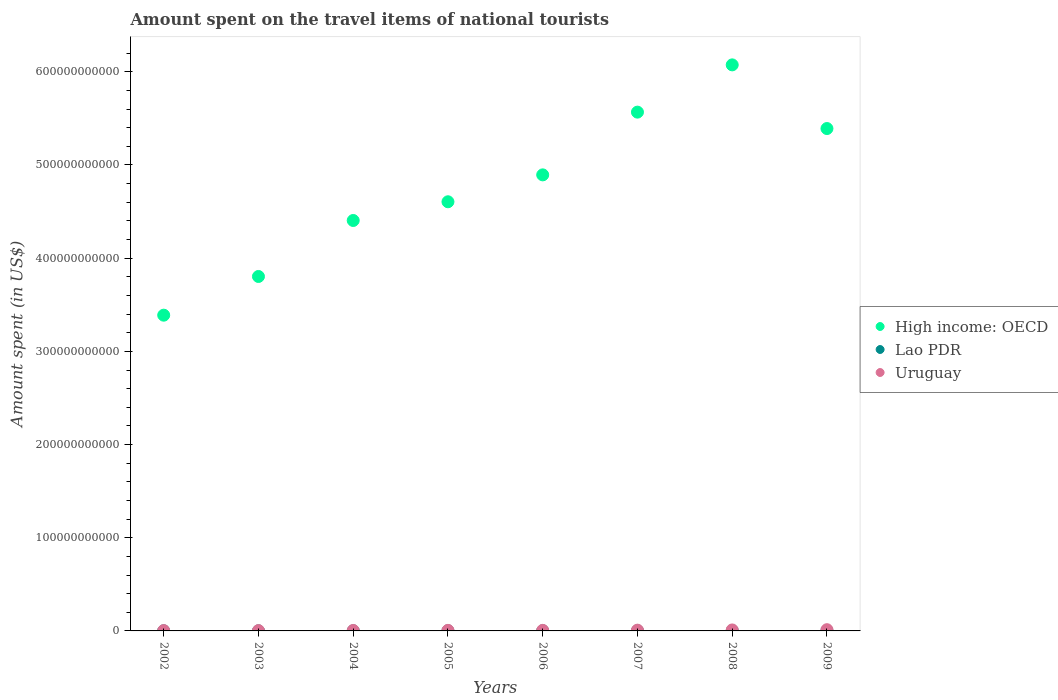How many different coloured dotlines are there?
Your answer should be very brief. 3. Is the number of dotlines equal to the number of legend labels?
Your response must be concise. Yes. What is the amount spent on the travel items of national tourists in High income: OECD in 2005?
Keep it short and to the point. 4.61e+11. Across all years, what is the maximum amount spent on the travel items of national tourists in Uruguay?
Ensure brevity in your answer.  1.32e+09. Across all years, what is the minimum amount spent on the travel items of national tourists in Lao PDR?
Make the answer very short. 7.40e+07. In which year was the amount spent on the travel items of national tourists in Lao PDR minimum?
Your response must be concise. 2003. What is the total amount spent on the travel items of national tourists in Lao PDR in the graph?
Offer a terse response. 1.33e+09. What is the difference between the amount spent on the travel items of national tourists in Lao PDR in 2004 and that in 2009?
Offer a terse response. -1.49e+08. What is the difference between the amount spent on the travel items of national tourists in Lao PDR in 2003 and the amount spent on the travel items of national tourists in Uruguay in 2009?
Keep it short and to the point. -1.25e+09. What is the average amount spent on the travel items of national tourists in High income: OECD per year?
Provide a succinct answer. 4.77e+11. In the year 2004, what is the difference between the amount spent on the travel items of national tourists in Lao PDR and amount spent on the travel items of national tourists in High income: OECD?
Provide a succinct answer. -4.40e+11. In how many years, is the amount spent on the travel items of national tourists in High income: OECD greater than 260000000000 US$?
Ensure brevity in your answer.  8. What is the ratio of the amount spent on the travel items of national tourists in Uruguay in 2006 to that in 2009?
Provide a short and direct response. 0.45. Is the difference between the amount spent on the travel items of national tourists in Lao PDR in 2006 and 2007 greater than the difference between the amount spent on the travel items of national tourists in High income: OECD in 2006 and 2007?
Provide a succinct answer. Yes. What is the difference between the highest and the second highest amount spent on the travel items of national tourists in High income: OECD?
Offer a terse response. 5.07e+1. What is the difference between the highest and the lowest amount spent on the travel items of national tourists in Lao PDR?
Provide a succinct answer. 2.02e+08. In how many years, is the amount spent on the travel items of national tourists in High income: OECD greater than the average amount spent on the travel items of national tourists in High income: OECD taken over all years?
Your answer should be compact. 4. Is it the case that in every year, the sum of the amount spent on the travel items of national tourists in High income: OECD and amount spent on the travel items of national tourists in Lao PDR  is greater than the amount spent on the travel items of national tourists in Uruguay?
Your response must be concise. Yes. Is the amount spent on the travel items of national tourists in Uruguay strictly greater than the amount spent on the travel items of national tourists in High income: OECD over the years?
Provide a short and direct response. No. Is the amount spent on the travel items of national tourists in High income: OECD strictly less than the amount spent on the travel items of national tourists in Uruguay over the years?
Give a very brief answer. No. How many years are there in the graph?
Make the answer very short. 8. What is the difference between two consecutive major ticks on the Y-axis?
Keep it short and to the point. 1.00e+11. Does the graph contain any zero values?
Your response must be concise. No. Does the graph contain grids?
Your answer should be compact. No. How are the legend labels stacked?
Offer a terse response. Vertical. What is the title of the graph?
Offer a very short reply. Amount spent on the travel items of national tourists. What is the label or title of the X-axis?
Your answer should be compact. Years. What is the label or title of the Y-axis?
Your answer should be very brief. Amount spent (in US$). What is the Amount spent (in US$) of High income: OECD in 2002?
Offer a terse response. 3.39e+11. What is the Amount spent (in US$) in Lao PDR in 2002?
Keep it short and to the point. 1.07e+08. What is the Amount spent (in US$) of Uruguay in 2002?
Provide a short and direct response. 3.51e+08. What is the Amount spent (in US$) of High income: OECD in 2003?
Keep it short and to the point. 3.80e+11. What is the Amount spent (in US$) in Lao PDR in 2003?
Ensure brevity in your answer.  7.40e+07. What is the Amount spent (in US$) of Uruguay in 2003?
Your answer should be very brief. 3.45e+08. What is the Amount spent (in US$) of High income: OECD in 2004?
Your response must be concise. 4.40e+11. What is the Amount spent (in US$) in Lao PDR in 2004?
Keep it short and to the point. 1.19e+08. What is the Amount spent (in US$) of Uruguay in 2004?
Offer a terse response. 4.94e+08. What is the Amount spent (in US$) in High income: OECD in 2005?
Keep it short and to the point. 4.61e+11. What is the Amount spent (in US$) of Lao PDR in 2005?
Keep it short and to the point. 1.39e+08. What is the Amount spent (in US$) in Uruguay in 2005?
Offer a very short reply. 5.94e+08. What is the Amount spent (in US$) in High income: OECD in 2006?
Ensure brevity in your answer.  4.89e+11. What is the Amount spent (in US$) of Lao PDR in 2006?
Your answer should be compact. 1.58e+08. What is the Amount spent (in US$) in Uruguay in 2006?
Ensure brevity in your answer.  5.98e+08. What is the Amount spent (in US$) in High income: OECD in 2007?
Provide a short and direct response. 5.57e+11. What is the Amount spent (in US$) in Lao PDR in 2007?
Offer a very short reply. 1.89e+08. What is the Amount spent (in US$) of Uruguay in 2007?
Offer a very short reply. 8.09e+08. What is the Amount spent (in US$) in High income: OECD in 2008?
Your response must be concise. 6.07e+11. What is the Amount spent (in US$) of Lao PDR in 2008?
Your answer should be very brief. 2.76e+08. What is the Amount spent (in US$) of Uruguay in 2008?
Offer a very short reply. 1.05e+09. What is the Amount spent (in US$) in High income: OECD in 2009?
Provide a short and direct response. 5.39e+11. What is the Amount spent (in US$) of Lao PDR in 2009?
Your answer should be compact. 2.68e+08. What is the Amount spent (in US$) in Uruguay in 2009?
Your response must be concise. 1.32e+09. Across all years, what is the maximum Amount spent (in US$) in High income: OECD?
Make the answer very short. 6.07e+11. Across all years, what is the maximum Amount spent (in US$) in Lao PDR?
Offer a very short reply. 2.76e+08. Across all years, what is the maximum Amount spent (in US$) in Uruguay?
Provide a short and direct response. 1.32e+09. Across all years, what is the minimum Amount spent (in US$) in High income: OECD?
Provide a succinct answer. 3.39e+11. Across all years, what is the minimum Amount spent (in US$) of Lao PDR?
Provide a succinct answer. 7.40e+07. Across all years, what is the minimum Amount spent (in US$) of Uruguay?
Ensure brevity in your answer.  3.45e+08. What is the total Amount spent (in US$) of High income: OECD in the graph?
Your answer should be very brief. 3.81e+12. What is the total Amount spent (in US$) of Lao PDR in the graph?
Offer a terse response. 1.33e+09. What is the total Amount spent (in US$) in Uruguay in the graph?
Your answer should be compact. 5.56e+09. What is the difference between the Amount spent (in US$) of High income: OECD in 2002 and that in 2003?
Make the answer very short. -4.15e+1. What is the difference between the Amount spent (in US$) of Lao PDR in 2002 and that in 2003?
Provide a succinct answer. 3.30e+07. What is the difference between the Amount spent (in US$) in High income: OECD in 2002 and that in 2004?
Offer a terse response. -1.02e+11. What is the difference between the Amount spent (in US$) in Lao PDR in 2002 and that in 2004?
Keep it short and to the point. -1.20e+07. What is the difference between the Amount spent (in US$) of Uruguay in 2002 and that in 2004?
Offer a terse response. -1.43e+08. What is the difference between the Amount spent (in US$) in High income: OECD in 2002 and that in 2005?
Your response must be concise. -1.22e+11. What is the difference between the Amount spent (in US$) in Lao PDR in 2002 and that in 2005?
Your answer should be compact. -3.20e+07. What is the difference between the Amount spent (in US$) in Uruguay in 2002 and that in 2005?
Make the answer very short. -2.43e+08. What is the difference between the Amount spent (in US$) of High income: OECD in 2002 and that in 2006?
Provide a succinct answer. -1.51e+11. What is the difference between the Amount spent (in US$) of Lao PDR in 2002 and that in 2006?
Provide a short and direct response. -5.10e+07. What is the difference between the Amount spent (in US$) of Uruguay in 2002 and that in 2006?
Offer a very short reply. -2.47e+08. What is the difference between the Amount spent (in US$) in High income: OECD in 2002 and that in 2007?
Your response must be concise. -2.18e+11. What is the difference between the Amount spent (in US$) of Lao PDR in 2002 and that in 2007?
Your answer should be very brief. -8.20e+07. What is the difference between the Amount spent (in US$) in Uruguay in 2002 and that in 2007?
Your response must be concise. -4.58e+08. What is the difference between the Amount spent (in US$) of High income: OECD in 2002 and that in 2008?
Your answer should be compact. -2.69e+11. What is the difference between the Amount spent (in US$) in Lao PDR in 2002 and that in 2008?
Offer a very short reply. -1.69e+08. What is the difference between the Amount spent (in US$) of Uruguay in 2002 and that in 2008?
Provide a succinct answer. -7.00e+08. What is the difference between the Amount spent (in US$) in High income: OECD in 2002 and that in 2009?
Your answer should be compact. -2.00e+11. What is the difference between the Amount spent (in US$) of Lao PDR in 2002 and that in 2009?
Your answer should be compact. -1.61e+08. What is the difference between the Amount spent (in US$) in Uruguay in 2002 and that in 2009?
Offer a very short reply. -9.70e+08. What is the difference between the Amount spent (in US$) in High income: OECD in 2003 and that in 2004?
Provide a succinct answer. -6.01e+1. What is the difference between the Amount spent (in US$) of Lao PDR in 2003 and that in 2004?
Your response must be concise. -4.50e+07. What is the difference between the Amount spent (in US$) in Uruguay in 2003 and that in 2004?
Make the answer very short. -1.49e+08. What is the difference between the Amount spent (in US$) of High income: OECD in 2003 and that in 2005?
Ensure brevity in your answer.  -8.02e+1. What is the difference between the Amount spent (in US$) of Lao PDR in 2003 and that in 2005?
Your answer should be very brief. -6.50e+07. What is the difference between the Amount spent (in US$) of Uruguay in 2003 and that in 2005?
Your answer should be very brief. -2.49e+08. What is the difference between the Amount spent (in US$) in High income: OECD in 2003 and that in 2006?
Give a very brief answer. -1.09e+11. What is the difference between the Amount spent (in US$) in Lao PDR in 2003 and that in 2006?
Keep it short and to the point. -8.40e+07. What is the difference between the Amount spent (in US$) in Uruguay in 2003 and that in 2006?
Your answer should be very brief. -2.53e+08. What is the difference between the Amount spent (in US$) of High income: OECD in 2003 and that in 2007?
Make the answer very short. -1.76e+11. What is the difference between the Amount spent (in US$) of Lao PDR in 2003 and that in 2007?
Your answer should be compact. -1.15e+08. What is the difference between the Amount spent (in US$) of Uruguay in 2003 and that in 2007?
Keep it short and to the point. -4.64e+08. What is the difference between the Amount spent (in US$) in High income: OECD in 2003 and that in 2008?
Your response must be concise. -2.27e+11. What is the difference between the Amount spent (in US$) of Lao PDR in 2003 and that in 2008?
Ensure brevity in your answer.  -2.02e+08. What is the difference between the Amount spent (in US$) in Uruguay in 2003 and that in 2008?
Ensure brevity in your answer.  -7.06e+08. What is the difference between the Amount spent (in US$) of High income: OECD in 2003 and that in 2009?
Your answer should be compact. -1.59e+11. What is the difference between the Amount spent (in US$) of Lao PDR in 2003 and that in 2009?
Provide a succinct answer. -1.94e+08. What is the difference between the Amount spent (in US$) of Uruguay in 2003 and that in 2009?
Provide a short and direct response. -9.76e+08. What is the difference between the Amount spent (in US$) in High income: OECD in 2004 and that in 2005?
Your answer should be very brief. -2.01e+1. What is the difference between the Amount spent (in US$) of Lao PDR in 2004 and that in 2005?
Your answer should be compact. -2.00e+07. What is the difference between the Amount spent (in US$) of Uruguay in 2004 and that in 2005?
Give a very brief answer. -1.00e+08. What is the difference between the Amount spent (in US$) in High income: OECD in 2004 and that in 2006?
Offer a terse response. -4.90e+1. What is the difference between the Amount spent (in US$) of Lao PDR in 2004 and that in 2006?
Give a very brief answer. -3.90e+07. What is the difference between the Amount spent (in US$) in Uruguay in 2004 and that in 2006?
Give a very brief answer. -1.04e+08. What is the difference between the Amount spent (in US$) in High income: OECD in 2004 and that in 2007?
Provide a short and direct response. -1.16e+11. What is the difference between the Amount spent (in US$) of Lao PDR in 2004 and that in 2007?
Your answer should be compact. -7.00e+07. What is the difference between the Amount spent (in US$) of Uruguay in 2004 and that in 2007?
Your response must be concise. -3.15e+08. What is the difference between the Amount spent (in US$) of High income: OECD in 2004 and that in 2008?
Offer a terse response. -1.67e+11. What is the difference between the Amount spent (in US$) of Lao PDR in 2004 and that in 2008?
Provide a succinct answer. -1.57e+08. What is the difference between the Amount spent (in US$) in Uruguay in 2004 and that in 2008?
Provide a short and direct response. -5.57e+08. What is the difference between the Amount spent (in US$) in High income: OECD in 2004 and that in 2009?
Offer a very short reply. -9.87e+1. What is the difference between the Amount spent (in US$) in Lao PDR in 2004 and that in 2009?
Ensure brevity in your answer.  -1.49e+08. What is the difference between the Amount spent (in US$) of Uruguay in 2004 and that in 2009?
Provide a short and direct response. -8.27e+08. What is the difference between the Amount spent (in US$) of High income: OECD in 2005 and that in 2006?
Your response must be concise. -2.89e+1. What is the difference between the Amount spent (in US$) in Lao PDR in 2005 and that in 2006?
Keep it short and to the point. -1.90e+07. What is the difference between the Amount spent (in US$) in Uruguay in 2005 and that in 2006?
Your response must be concise. -4.00e+06. What is the difference between the Amount spent (in US$) in High income: OECD in 2005 and that in 2007?
Your response must be concise. -9.62e+1. What is the difference between the Amount spent (in US$) of Lao PDR in 2005 and that in 2007?
Offer a terse response. -5.00e+07. What is the difference between the Amount spent (in US$) of Uruguay in 2005 and that in 2007?
Keep it short and to the point. -2.15e+08. What is the difference between the Amount spent (in US$) of High income: OECD in 2005 and that in 2008?
Provide a short and direct response. -1.47e+11. What is the difference between the Amount spent (in US$) of Lao PDR in 2005 and that in 2008?
Offer a terse response. -1.37e+08. What is the difference between the Amount spent (in US$) in Uruguay in 2005 and that in 2008?
Ensure brevity in your answer.  -4.57e+08. What is the difference between the Amount spent (in US$) of High income: OECD in 2005 and that in 2009?
Your response must be concise. -7.86e+1. What is the difference between the Amount spent (in US$) in Lao PDR in 2005 and that in 2009?
Ensure brevity in your answer.  -1.29e+08. What is the difference between the Amount spent (in US$) in Uruguay in 2005 and that in 2009?
Keep it short and to the point. -7.27e+08. What is the difference between the Amount spent (in US$) in High income: OECD in 2006 and that in 2007?
Provide a short and direct response. -6.73e+1. What is the difference between the Amount spent (in US$) in Lao PDR in 2006 and that in 2007?
Keep it short and to the point. -3.10e+07. What is the difference between the Amount spent (in US$) in Uruguay in 2006 and that in 2007?
Ensure brevity in your answer.  -2.11e+08. What is the difference between the Amount spent (in US$) in High income: OECD in 2006 and that in 2008?
Your response must be concise. -1.18e+11. What is the difference between the Amount spent (in US$) in Lao PDR in 2006 and that in 2008?
Provide a succinct answer. -1.18e+08. What is the difference between the Amount spent (in US$) in Uruguay in 2006 and that in 2008?
Ensure brevity in your answer.  -4.53e+08. What is the difference between the Amount spent (in US$) in High income: OECD in 2006 and that in 2009?
Your answer should be very brief. -4.97e+1. What is the difference between the Amount spent (in US$) of Lao PDR in 2006 and that in 2009?
Offer a terse response. -1.10e+08. What is the difference between the Amount spent (in US$) of Uruguay in 2006 and that in 2009?
Provide a short and direct response. -7.23e+08. What is the difference between the Amount spent (in US$) in High income: OECD in 2007 and that in 2008?
Your response must be concise. -5.07e+1. What is the difference between the Amount spent (in US$) in Lao PDR in 2007 and that in 2008?
Provide a short and direct response. -8.70e+07. What is the difference between the Amount spent (in US$) in Uruguay in 2007 and that in 2008?
Ensure brevity in your answer.  -2.42e+08. What is the difference between the Amount spent (in US$) in High income: OECD in 2007 and that in 2009?
Your answer should be compact. 1.76e+1. What is the difference between the Amount spent (in US$) in Lao PDR in 2007 and that in 2009?
Provide a succinct answer. -7.90e+07. What is the difference between the Amount spent (in US$) in Uruguay in 2007 and that in 2009?
Offer a very short reply. -5.12e+08. What is the difference between the Amount spent (in US$) of High income: OECD in 2008 and that in 2009?
Provide a short and direct response. 6.83e+1. What is the difference between the Amount spent (in US$) of Lao PDR in 2008 and that in 2009?
Your answer should be very brief. 8.00e+06. What is the difference between the Amount spent (in US$) of Uruguay in 2008 and that in 2009?
Keep it short and to the point. -2.70e+08. What is the difference between the Amount spent (in US$) of High income: OECD in 2002 and the Amount spent (in US$) of Lao PDR in 2003?
Your answer should be compact. 3.39e+11. What is the difference between the Amount spent (in US$) in High income: OECD in 2002 and the Amount spent (in US$) in Uruguay in 2003?
Make the answer very short. 3.38e+11. What is the difference between the Amount spent (in US$) in Lao PDR in 2002 and the Amount spent (in US$) in Uruguay in 2003?
Provide a succinct answer. -2.38e+08. What is the difference between the Amount spent (in US$) in High income: OECD in 2002 and the Amount spent (in US$) in Lao PDR in 2004?
Provide a succinct answer. 3.39e+11. What is the difference between the Amount spent (in US$) in High income: OECD in 2002 and the Amount spent (in US$) in Uruguay in 2004?
Your answer should be compact. 3.38e+11. What is the difference between the Amount spent (in US$) in Lao PDR in 2002 and the Amount spent (in US$) in Uruguay in 2004?
Your response must be concise. -3.87e+08. What is the difference between the Amount spent (in US$) in High income: OECD in 2002 and the Amount spent (in US$) in Lao PDR in 2005?
Ensure brevity in your answer.  3.39e+11. What is the difference between the Amount spent (in US$) of High income: OECD in 2002 and the Amount spent (in US$) of Uruguay in 2005?
Your answer should be very brief. 3.38e+11. What is the difference between the Amount spent (in US$) in Lao PDR in 2002 and the Amount spent (in US$) in Uruguay in 2005?
Your response must be concise. -4.87e+08. What is the difference between the Amount spent (in US$) of High income: OECD in 2002 and the Amount spent (in US$) of Lao PDR in 2006?
Provide a succinct answer. 3.39e+11. What is the difference between the Amount spent (in US$) of High income: OECD in 2002 and the Amount spent (in US$) of Uruguay in 2006?
Offer a terse response. 3.38e+11. What is the difference between the Amount spent (in US$) in Lao PDR in 2002 and the Amount spent (in US$) in Uruguay in 2006?
Keep it short and to the point. -4.91e+08. What is the difference between the Amount spent (in US$) in High income: OECD in 2002 and the Amount spent (in US$) in Lao PDR in 2007?
Give a very brief answer. 3.39e+11. What is the difference between the Amount spent (in US$) of High income: OECD in 2002 and the Amount spent (in US$) of Uruguay in 2007?
Keep it short and to the point. 3.38e+11. What is the difference between the Amount spent (in US$) in Lao PDR in 2002 and the Amount spent (in US$) in Uruguay in 2007?
Your answer should be compact. -7.02e+08. What is the difference between the Amount spent (in US$) of High income: OECD in 2002 and the Amount spent (in US$) of Lao PDR in 2008?
Keep it short and to the point. 3.39e+11. What is the difference between the Amount spent (in US$) of High income: OECD in 2002 and the Amount spent (in US$) of Uruguay in 2008?
Keep it short and to the point. 3.38e+11. What is the difference between the Amount spent (in US$) of Lao PDR in 2002 and the Amount spent (in US$) of Uruguay in 2008?
Make the answer very short. -9.44e+08. What is the difference between the Amount spent (in US$) of High income: OECD in 2002 and the Amount spent (in US$) of Lao PDR in 2009?
Make the answer very short. 3.39e+11. What is the difference between the Amount spent (in US$) of High income: OECD in 2002 and the Amount spent (in US$) of Uruguay in 2009?
Your response must be concise. 3.38e+11. What is the difference between the Amount spent (in US$) of Lao PDR in 2002 and the Amount spent (in US$) of Uruguay in 2009?
Offer a very short reply. -1.21e+09. What is the difference between the Amount spent (in US$) of High income: OECD in 2003 and the Amount spent (in US$) of Lao PDR in 2004?
Your answer should be compact. 3.80e+11. What is the difference between the Amount spent (in US$) in High income: OECD in 2003 and the Amount spent (in US$) in Uruguay in 2004?
Keep it short and to the point. 3.80e+11. What is the difference between the Amount spent (in US$) in Lao PDR in 2003 and the Amount spent (in US$) in Uruguay in 2004?
Offer a very short reply. -4.20e+08. What is the difference between the Amount spent (in US$) in High income: OECD in 2003 and the Amount spent (in US$) in Lao PDR in 2005?
Keep it short and to the point. 3.80e+11. What is the difference between the Amount spent (in US$) of High income: OECD in 2003 and the Amount spent (in US$) of Uruguay in 2005?
Offer a very short reply. 3.80e+11. What is the difference between the Amount spent (in US$) in Lao PDR in 2003 and the Amount spent (in US$) in Uruguay in 2005?
Offer a terse response. -5.20e+08. What is the difference between the Amount spent (in US$) in High income: OECD in 2003 and the Amount spent (in US$) in Lao PDR in 2006?
Keep it short and to the point. 3.80e+11. What is the difference between the Amount spent (in US$) of High income: OECD in 2003 and the Amount spent (in US$) of Uruguay in 2006?
Keep it short and to the point. 3.80e+11. What is the difference between the Amount spent (in US$) in Lao PDR in 2003 and the Amount spent (in US$) in Uruguay in 2006?
Provide a short and direct response. -5.24e+08. What is the difference between the Amount spent (in US$) of High income: OECD in 2003 and the Amount spent (in US$) of Lao PDR in 2007?
Ensure brevity in your answer.  3.80e+11. What is the difference between the Amount spent (in US$) of High income: OECD in 2003 and the Amount spent (in US$) of Uruguay in 2007?
Provide a succinct answer. 3.80e+11. What is the difference between the Amount spent (in US$) of Lao PDR in 2003 and the Amount spent (in US$) of Uruguay in 2007?
Your answer should be compact. -7.35e+08. What is the difference between the Amount spent (in US$) in High income: OECD in 2003 and the Amount spent (in US$) in Lao PDR in 2008?
Ensure brevity in your answer.  3.80e+11. What is the difference between the Amount spent (in US$) of High income: OECD in 2003 and the Amount spent (in US$) of Uruguay in 2008?
Your response must be concise. 3.79e+11. What is the difference between the Amount spent (in US$) of Lao PDR in 2003 and the Amount spent (in US$) of Uruguay in 2008?
Make the answer very short. -9.77e+08. What is the difference between the Amount spent (in US$) in High income: OECD in 2003 and the Amount spent (in US$) in Lao PDR in 2009?
Ensure brevity in your answer.  3.80e+11. What is the difference between the Amount spent (in US$) of High income: OECD in 2003 and the Amount spent (in US$) of Uruguay in 2009?
Offer a terse response. 3.79e+11. What is the difference between the Amount spent (in US$) of Lao PDR in 2003 and the Amount spent (in US$) of Uruguay in 2009?
Provide a short and direct response. -1.25e+09. What is the difference between the Amount spent (in US$) of High income: OECD in 2004 and the Amount spent (in US$) of Lao PDR in 2005?
Your response must be concise. 4.40e+11. What is the difference between the Amount spent (in US$) in High income: OECD in 2004 and the Amount spent (in US$) in Uruguay in 2005?
Your answer should be compact. 4.40e+11. What is the difference between the Amount spent (in US$) in Lao PDR in 2004 and the Amount spent (in US$) in Uruguay in 2005?
Your answer should be very brief. -4.75e+08. What is the difference between the Amount spent (in US$) in High income: OECD in 2004 and the Amount spent (in US$) in Lao PDR in 2006?
Ensure brevity in your answer.  4.40e+11. What is the difference between the Amount spent (in US$) of High income: OECD in 2004 and the Amount spent (in US$) of Uruguay in 2006?
Provide a short and direct response. 4.40e+11. What is the difference between the Amount spent (in US$) in Lao PDR in 2004 and the Amount spent (in US$) in Uruguay in 2006?
Give a very brief answer. -4.79e+08. What is the difference between the Amount spent (in US$) in High income: OECD in 2004 and the Amount spent (in US$) in Lao PDR in 2007?
Ensure brevity in your answer.  4.40e+11. What is the difference between the Amount spent (in US$) of High income: OECD in 2004 and the Amount spent (in US$) of Uruguay in 2007?
Give a very brief answer. 4.40e+11. What is the difference between the Amount spent (in US$) of Lao PDR in 2004 and the Amount spent (in US$) of Uruguay in 2007?
Your answer should be compact. -6.90e+08. What is the difference between the Amount spent (in US$) in High income: OECD in 2004 and the Amount spent (in US$) in Lao PDR in 2008?
Your answer should be compact. 4.40e+11. What is the difference between the Amount spent (in US$) in High income: OECD in 2004 and the Amount spent (in US$) in Uruguay in 2008?
Give a very brief answer. 4.39e+11. What is the difference between the Amount spent (in US$) in Lao PDR in 2004 and the Amount spent (in US$) in Uruguay in 2008?
Your answer should be compact. -9.32e+08. What is the difference between the Amount spent (in US$) in High income: OECD in 2004 and the Amount spent (in US$) in Lao PDR in 2009?
Your answer should be compact. 4.40e+11. What is the difference between the Amount spent (in US$) in High income: OECD in 2004 and the Amount spent (in US$) in Uruguay in 2009?
Your answer should be very brief. 4.39e+11. What is the difference between the Amount spent (in US$) in Lao PDR in 2004 and the Amount spent (in US$) in Uruguay in 2009?
Ensure brevity in your answer.  -1.20e+09. What is the difference between the Amount spent (in US$) of High income: OECD in 2005 and the Amount spent (in US$) of Lao PDR in 2006?
Offer a very short reply. 4.60e+11. What is the difference between the Amount spent (in US$) of High income: OECD in 2005 and the Amount spent (in US$) of Uruguay in 2006?
Offer a very short reply. 4.60e+11. What is the difference between the Amount spent (in US$) of Lao PDR in 2005 and the Amount spent (in US$) of Uruguay in 2006?
Keep it short and to the point. -4.59e+08. What is the difference between the Amount spent (in US$) in High income: OECD in 2005 and the Amount spent (in US$) in Lao PDR in 2007?
Offer a very short reply. 4.60e+11. What is the difference between the Amount spent (in US$) in High income: OECD in 2005 and the Amount spent (in US$) in Uruguay in 2007?
Provide a succinct answer. 4.60e+11. What is the difference between the Amount spent (in US$) in Lao PDR in 2005 and the Amount spent (in US$) in Uruguay in 2007?
Keep it short and to the point. -6.70e+08. What is the difference between the Amount spent (in US$) in High income: OECD in 2005 and the Amount spent (in US$) in Lao PDR in 2008?
Ensure brevity in your answer.  4.60e+11. What is the difference between the Amount spent (in US$) in High income: OECD in 2005 and the Amount spent (in US$) in Uruguay in 2008?
Keep it short and to the point. 4.59e+11. What is the difference between the Amount spent (in US$) in Lao PDR in 2005 and the Amount spent (in US$) in Uruguay in 2008?
Your response must be concise. -9.12e+08. What is the difference between the Amount spent (in US$) of High income: OECD in 2005 and the Amount spent (in US$) of Lao PDR in 2009?
Your response must be concise. 4.60e+11. What is the difference between the Amount spent (in US$) of High income: OECD in 2005 and the Amount spent (in US$) of Uruguay in 2009?
Your response must be concise. 4.59e+11. What is the difference between the Amount spent (in US$) in Lao PDR in 2005 and the Amount spent (in US$) in Uruguay in 2009?
Your response must be concise. -1.18e+09. What is the difference between the Amount spent (in US$) in High income: OECD in 2006 and the Amount spent (in US$) in Lao PDR in 2007?
Provide a short and direct response. 4.89e+11. What is the difference between the Amount spent (in US$) in High income: OECD in 2006 and the Amount spent (in US$) in Uruguay in 2007?
Your answer should be compact. 4.89e+11. What is the difference between the Amount spent (in US$) of Lao PDR in 2006 and the Amount spent (in US$) of Uruguay in 2007?
Give a very brief answer. -6.51e+08. What is the difference between the Amount spent (in US$) of High income: OECD in 2006 and the Amount spent (in US$) of Lao PDR in 2008?
Offer a terse response. 4.89e+11. What is the difference between the Amount spent (in US$) of High income: OECD in 2006 and the Amount spent (in US$) of Uruguay in 2008?
Your answer should be compact. 4.88e+11. What is the difference between the Amount spent (in US$) in Lao PDR in 2006 and the Amount spent (in US$) in Uruguay in 2008?
Make the answer very short. -8.93e+08. What is the difference between the Amount spent (in US$) in High income: OECD in 2006 and the Amount spent (in US$) in Lao PDR in 2009?
Your answer should be very brief. 4.89e+11. What is the difference between the Amount spent (in US$) of High income: OECD in 2006 and the Amount spent (in US$) of Uruguay in 2009?
Offer a terse response. 4.88e+11. What is the difference between the Amount spent (in US$) of Lao PDR in 2006 and the Amount spent (in US$) of Uruguay in 2009?
Your answer should be very brief. -1.16e+09. What is the difference between the Amount spent (in US$) of High income: OECD in 2007 and the Amount spent (in US$) of Lao PDR in 2008?
Keep it short and to the point. 5.56e+11. What is the difference between the Amount spent (in US$) in High income: OECD in 2007 and the Amount spent (in US$) in Uruguay in 2008?
Your response must be concise. 5.56e+11. What is the difference between the Amount spent (in US$) of Lao PDR in 2007 and the Amount spent (in US$) of Uruguay in 2008?
Provide a short and direct response. -8.62e+08. What is the difference between the Amount spent (in US$) of High income: OECD in 2007 and the Amount spent (in US$) of Lao PDR in 2009?
Provide a short and direct response. 5.56e+11. What is the difference between the Amount spent (in US$) of High income: OECD in 2007 and the Amount spent (in US$) of Uruguay in 2009?
Make the answer very short. 5.55e+11. What is the difference between the Amount spent (in US$) of Lao PDR in 2007 and the Amount spent (in US$) of Uruguay in 2009?
Keep it short and to the point. -1.13e+09. What is the difference between the Amount spent (in US$) in High income: OECD in 2008 and the Amount spent (in US$) in Lao PDR in 2009?
Your answer should be compact. 6.07e+11. What is the difference between the Amount spent (in US$) of High income: OECD in 2008 and the Amount spent (in US$) of Uruguay in 2009?
Ensure brevity in your answer.  6.06e+11. What is the difference between the Amount spent (in US$) of Lao PDR in 2008 and the Amount spent (in US$) of Uruguay in 2009?
Ensure brevity in your answer.  -1.04e+09. What is the average Amount spent (in US$) of High income: OECD per year?
Offer a very short reply. 4.77e+11. What is the average Amount spent (in US$) in Lao PDR per year?
Make the answer very short. 1.66e+08. What is the average Amount spent (in US$) in Uruguay per year?
Provide a short and direct response. 6.95e+08. In the year 2002, what is the difference between the Amount spent (in US$) of High income: OECD and Amount spent (in US$) of Lao PDR?
Ensure brevity in your answer.  3.39e+11. In the year 2002, what is the difference between the Amount spent (in US$) in High income: OECD and Amount spent (in US$) in Uruguay?
Your answer should be very brief. 3.38e+11. In the year 2002, what is the difference between the Amount spent (in US$) in Lao PDR and Amount spent (in US$) in Uruguay?
Your answer should be very brief. -2.44e+08. In the year 2003, what is the difference between the Amount spent (in US$) of High income: OECD and Amount spent (in US$) of Lao PDR?
Offer a very short reply. 3.80e+11. In the year 2003, what is the difference between the Amount spent (in US$) in High income: OECD and Amount spent (in US$) in Uruguay?
Your response must be concise. 3.80e+11. In the year 2003, what is the difference between the Amount spent (in US$) in Lao PDR and Amount spent (in US$) in Uruguay?
Offer a very short reply. -2.71e+08. In the year 2004, what is the difference between the Amount spent (in US$) in High income: OECD and Amount spent (in US$) in Lao PDR?
Make the answer very short. 4.40e+11. In the year 2004, what is the difference between the Amount spent (in US$) in High income: OECD and Amount spent (in US$) in Uruguay?
Give a very brief answer. 4.40e+11. In the year 2004, what is the difference between the Amount spent (in US$) in Lao PDR and Amount spent (in US$) in Uruguay?
Provide a succinct answer. -3.75e+08. In the year 2005, what is the difference between the Amount spent (in US$) in High income: OECD and Amount spent (in US$) in Lao PDR?
Make the answer very short. 4.60e+11. In the year 2005, what is the difference between the Amount spent (in US$) of High income: OECD and Amount spent (in US$) of Uruguay?
Your response must be concise. 4.60e+11. In the year 2005, what is the difference between the Amount spent (in US$) of Lao PDR and Amount spent (in US$) of Uruguay?
Provide a succinct answer. -4.55e+08. In the year 2006, what is the difference between the Amount spent (in US$) of High income: OECD and Amount spent (in US$) of Lao PDR?
Provide a succinct answer. 4.89e+11. In the year 2006, what is the difference between the Amount spent (in US$) of High income: OECD and Amount spent (in US$) of Uruguay?
Your response must be concise. 4.89e+11. In the year 2006, what is the difference between the Amount spent (in US$) in Lao PDR and Amount spent (in US$) in Uruguay?
Keep it short and to the point. -4.40e+08. In the year 2007, what is the difference between the Amount spent (in US$) of High income: OECD and Amount spent (in US$) of Lao PDR?
Offer a very short reply. 5.57e+11. In the year 2007, what is the difference between the Amount spent (in US$) in High income: OECD and Amount spent (in US$) in Uruguay?
Your answer should be compact. 5.56e+11. In the year 2007, what is the difference between the Amount spent (in US$) in Lao PDR and Amount spent (in US$) in Uruguay?
Provide a short and direct response. -6.20e+08. In the year 2008, what is the difference between the Amount spent (in US$) of High income: OECD and Amount spent (in US$) of Lao PDR?
Your answer should be very brief. 6.07e+11. In the year 2008, what is the difference between the Amount spent (in US$) in High income: OECD and Amount spent (in US$) in Uruguay?
Ensure brevity in your answer.  6.06e+11. In the year 2008, what is the difference between the Amount spent (in US$) in Lao PDR and Amount spent (in US$) in Uruguay?
Your answer should be very brief. -7.75e+08. In the year 2009, what is the difference between the Amount spent (in US$) of High income: OECD and Amount spent (in US$) of Lao PDR?
Your answer should be compact. 5.39e+11. In the year 2009, what is the difference between the Amount spent (in US$) of High income: OECD and Amount spent (in US$) of Uruguay?
Your answer should be very brief. 5.38e+11. In the year 2009, what is the difference between the Amount spent (in US$) in Lao PDR and Amount spent (in US$) in Uruguay?
Your answer should be very brief. -1.05e+09. What is the ratio of the Amount spent (in US$) in High income: OECD in 2002 to that in 2003?
Your response must be concise. 0.89. What is the ratio of the Amount spent (in US$) of Lao PDR in 2002 to that in 2003?
Give a very brief answer. 1.45. What is the ratio of the Amount spent (in US$) of Uruguay in 2002 to that in 2003?
Keep it short and to the point. 1.02. What is the ratio of the Amount spent (in US$) in High income: OECD in 2002 to that in 2004?
Provide a succinct answer. 0.77. What is the ratio of the Amount spent (in US$) in Lao PDR in 2002 to that in 2004?
Your response must be concise. 0.9. What is the ratio of the Amount spent (in US$) in Uruguay in 2002 to that in 2004?
Provide a short and direct response. 0.71. What is the ratio of the Amount spent (in US$) in High income: OECD in 2002 to that in 2005?
Offer a very short reply. 0.74. What is the ratio of the Amount spent (in US$) in Lao PDR in 2002 to that in 2005?
Offer a terse response. 0.77. What is the ratio of the Amount spent (in US$) of Uruguay in 2002 to that in 2005?
Your response must be concise. 0.59. What is the ratio of the Amount spent (in US$) of High income: OECD in 2002 to that in 2006?
Provide a succinct answer. 0.69. What is the ratio of the Amount spent (in US$) in Lao PDR in 2002 to that in 2006?
Provide a succinct answer. 0.68. What is the ratio of the Amount spent (in US$) of Uruguay in 2002 to that in 2006?
Your answer should be compact. 0.59. What is the ratio of the Amount spent (in US$) in High income: OECD in 2002 to that in 2007?
Provide a succinct answer. 0.61. What is the ratio of the Amount spent (in US$) of Lao PDR in 2002 to that in 2007?
Offer a very short reply. 0.57. What is the ratio of the Amount spent (in US$) in Uruguay in 2002 to that in 2007?
Your answer should be compact. 0.43. What is the ratio of the Amount spent (in US$) in High income: OECD in 2002 to that in 2008?
Give a very brief answer. 0.56. What is the ratio of the Amount spent (in US$) of Lao PDR in 2002 to that in 2008?
Provide a short and direct response. 0.39. What is the ratio of the Amount spent (in US$) of Uruguay in 2002 to that in 2008?
Give a very brief answer. 0.33. What is the ratio of the Amount spent (in US$) in High income: OECD in 2002 to that in 2009?
Offer a very short reply. 0.63. What is the ratio of the Amount spent (in US$) in Lao PDR in 2002 to that in 2009?
Make the answer very short. 0.4. What is the ratio of the Amount spent (in US$) in Uruguay in 2002 to that in 2009?
Offer a terse response. 0.27. What is the ratio of the Amount spent (in US$) in High income: OECD in 2003 to that in 2004?
Keep it short and to the point. 0.86. What is the ratio of the Amount spent (in US$) of Lao PDR in 2003 to that in 2004?
Your response must be concise. 0.62. What is the ratio of the Amount spent (in US$) in Uruguay in 2003 to that in 2004?
Your answer should be very brief. 0.7. What is the ratio of the Amount spent (in US$) in High income: OECD in 2003 to that in 2005?
Make the answer very short. 0.83. What is the ratio of the Amount spent (in US$) of Lao PDR in 2003 to that in 2005?
Keep it short and to the point. 0.53. What is the ratio of the Amount spent (in US$) of Uruguay in 2003 to that in 2005?
Give a very brief answer. 0.58. What is the ratio of the Amount spent (in US$) in High income: OECD in 2003 to that in 2006?
Keep it short and to the point. 0.78. What is the ratio of the Amount spent (in US$) in Lao PDR in 2003 to that in 2006?
Make the answer very short. 0.47. What is the ratio of the Amount spent (in US$) in Uruguay in 2003 to that in 2006?
Give a very brief answer. 0.58. What is the ratio of the Amount spent (in US$) in High income: OECD in 2003 to that in 2007?
Ensure brevity in your answer.  0.68. What is the ratio of the Amount spent (in US$) in Lao PDR in 2003 to that in 2007?
Ensure brevity in your answer.  0.39. What is the ratio of the Amount spent (in US$) in Uruguay in 2003 to that in 2007?
Give a very brief answer. 0.43. What is the ratio of the Amount spent (in US$) of High income: OECD in 2003 to that in 2008?
Keep it short and to the point. 0.63. What is the ratio of the Amount spent (in US$) in Lao PDR in 2003 to that in 2008?
Give a very brief answer. 0.27. What is the ratio of the Amount spent (in US$) of Uruguay in 2003 to that in 2008?
Offer a very short reply. 0.33. What is the ratio of the Amount spent (in US$) of High income: OECD in 2003 to that in 2009?
Your answer should be very brief. 0.71. What is the ratio of the Amount spent (in US$) in Lao PDR in 2003 to that in 2009?
Provide a succinct answer. 0.28. What is the ratio of the Amount spent (in US$) of Uruguay in 2003 to that in 2009?
Ensure brevity in your answer.  0.26. What is the ratio of the Amount spent (in US$) in High income: OECD in 2004 to that in 2005?
Your answer should be very brief. 0.96. What is the ratio of the Amount spent (in US$) in Lao PDR in 2004 to that in 2005?
Make the answer very short. 0.86. What is the ratio of the Amount spent (in US$) of Uruguay in 2004 to that in 2005?
Give a very brief answer. 0.83. What is the ratio of the Amount spent (in US$) of Lao PDR in 2004 to that in 2006?
Ensure brevity in your answer.  0.75. What is the ratio of the Amount spent (in US$) of Uruguay in 2004 to that in 2006?
Offer a terse response. 0.83. What is the ratio of the Amount spent (in US$) of High income: OECD in 2004 to that in 2007?
Offer a terse response. 0.79. What is the ratio of the Amount spent (in US$) in Lao PDR in 2004 to that in 2007?
Provide a short and direct response. 0.63. What is the ratio of the Amount spent (in US$) of Uruguay in 2004 to that in 2007?
Provide a short and direct response. 0.61. What is the ratio of the Amount spent (in US$) of High income: OECD in 2004 to that in 2008?
Offer a very short reply. 0.73. What is the ratio of the Amount spent (in US$) in Lao PDR in 2004 to that in 2008?
Offer a terse response. 0.43. What is the ratio of the Amount spent (in US$) in Uruguay in 2004 to that in 2008?
Your answer should be compact. 0.47. What is the ratio of the Amount spent (in US$) in High income: OECD in 2004 to that in 2009?
Offer a very short reply. 0.82. What is the ratio of the Amount spent (in US$) of Lao PDR in 2004 to that in 2009?
Your response must be concise. 0.44. What is the ratio of the Amount spent (in US$) of Uruguay in 2004 to that in 2009?
Make the answer very short. 0.37. What is the ratio of the Amount spent (in US$) of High income: OECD in 2005 to that in 2006?
Provide a short and direct response. 0.94. What is the ratio of the Amount spent (in US$) in Lao PDR in 2005 to that in 2006?
Make the answer very short. 0.88. What is the ratio of the Amount spent (in US$) of Uruguay in 2005 to that in 2006?
Make the answer very short. 0.99. What is the ratio of the Amount spent (in US$) of High income: OECD in 2005 to that in 2007?
Your answer should be very brief. 0.83. What is the ratio of the Amount spent (in US$) in Lao PDR in 2005 to that in 2007?
Keep it short and to the point. 0.74. What is the ratio of the Amount spent (in US$) of Uruguay in 2005 to that in 2007?
Your answer should be very brief. 0.73. What is the ratio of the Amount spent (in US$) of High income: OECD in 2005 to that in 2008?
Offer a very short reply. 0.76. What is the ratio of the Amount spent (in US$) in Lao PDR in 2005 to that in 2008?
Provide a succinct answer. 0.5. What is the ratio of the Amount spent (in US$) in Uruguay in 2005 to that in 2008?
Your answer should be very brief. 0.57. What is the ratio of the Amount spent (in US$) of High income: OECD in 2005 to that in 2009?
Your response must be concise. 0.85. What is the ratio of the Amount spent (in US$) of Lao PDR in 2005 to that in 2009?
Provide a short and direct response. 0.52. What is the ratio of the Amount spent (in US$) in Uruguay in 2005 to that in 2009?
Your response must be concise. 0.45. What is the ratio of the Amount spent (in US$) of High income: OECD in 2006 to that in 2007?
Provide a short and direct response. 0.88. What is the ratio of the Amount spent (in US$) in Lao PDR in 2006 to that in 2007?
Your response must be concise. 0.84. What is the ratio of the Amount spent (in US$) of Uruguay in 2006 to that in 2007?
Make the answer very short. 0.74. What is the ratio of the Amount spent (in US$) in High income: OECD in 2006 to that in 2008?
Offer a terse response. 0.81. What is the ratio of the Amount spent (in US$) in Lao PDR in 2006 to that in 2008?
Your answer should be compact. 0.57. What is the ratio of the Amount spent (in US$) in Uruguay in 2006 to that in 2008?
Provide a succinct answer. 0.57. What is the ratio of the Amount spent (in US$) in High income: OECD in 2006 to that in 2009?
Offer a terse response. 0.91. What is the ratio of the Amount spent (in US$) in Lao PDR in 2006 to that in 2009?
Keep it short and to the point. 0.59. What is the ratio of the Amount spent (in US$) of Uruguay in 2006 to that in 2009?
Your answer should be very brief. 0.45. What is the ratio of the Amount spent (in US$) of High income: OECD in 2007 to that in 2008?
Keep it short and to the point. 0.92. What is the ratio of the Amount spent (in US$) of Lao PDR in 2007 to that in 2008?
Offer a terse response. 0.68. What is the ratio of the Amount spent (in US$) of Uruguay in 2007 to that in 2008?
Your answer should be very brief. 0.77. What is the ratio of the Amount spent (in US$) in High income: OECD in 2007 to that in 2009?
Provide a succinct answer. 1.03. What is the ratio of the Amount spent (in US$) of Lao PDR in 2007 to that in 2009?
Your answer should be very brief. 0.71. What is the ratio of the Amount spent (in US$) of Uruguay in 2007 to that in 2009?
Provide a short and direct response. 0.61. What is the ratio of the Amount spent (in US$) of High income: OECD in 2008 to that in 2009?
Offer a terse response. 1.13. What is the ratio of the Amount spent (in US$) of Lao PDR in 2008 to that in 2009?
Provide a short and direct response. 1.03. What is the ratio of the Amount spent (in US$) in Uruguay in 2008 to that in 2009?
Offer a terse response. 0.8. What is the difference between the highest and the second highest Amount spent (in US$) of High income: OECD?
Your response must be concise. 5.07e+1. What is the difference between the highest and the second highest Amount spent (in US$) of Uruguay?
Provide a succinct answer. 2.70e+08. What is the difference between the highest and the lowest Amount spent (in US$) of High income: OECD?
Keep it short and to the point. 2.69e+11. What is the difference between the highest and the lowest Amount spent (in US$) of Lao PDR?
Provide a short and direct response. 2.02e+08. What is the difference between the highest and the lowest Amount spent (in US$) in Uruguay?
Offer a very short reply. 9.76e+08. 